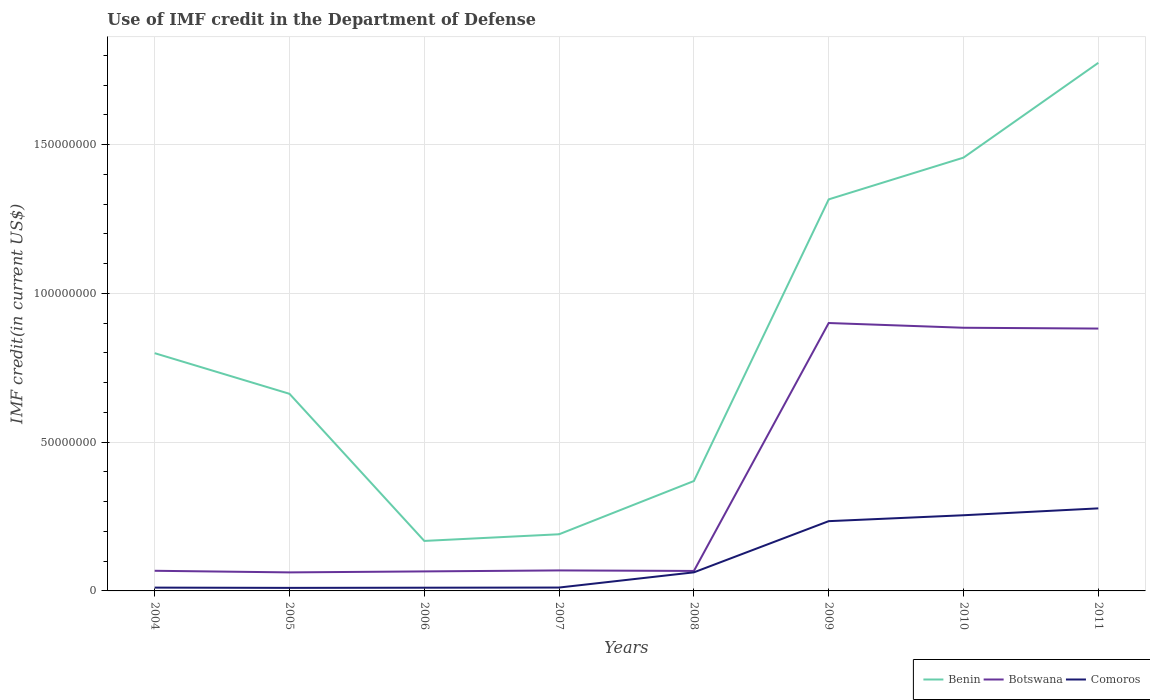How many different coloured lines are there?
Your answer should be compact. 3. Does the line corresponding to Comoros intersect with the line corresponding to Botswana?
Your answer should be compact. No. Is the number of lines equal to the number of legend labels?
Give a very brief answer. Yes. Across all years, what is the maximum IMF credit in the Department of Defense in Comoros?
Keep it short and to the point. 1.02e+06. What is the total IMF credit in the Department of Defense in Botswana in the graph?
Your response must be concise. -3.30e+05. What is the difference between the highest and the second highest IMF credit in the Department of Defense in Benin?
Keep it short and to the point. 1.61e+08. Is the IMF credit in the Department of Defense in Benin strictly greater than the IMF credit in the Department of Defense in Botswana over the years?
Give a very brief answer. No. How many lines are there?
Make the answer very short. 3. What is the difference between two consecutive major ticks on the Y-axis?
Make the answer very short. 5.00e+07. Where does the legend appear in the graph?
Provide a succinct answer. Bottom right. How many legend labels are there?
Ensure brevity in your answer.  3. What is the title of the graph?
Provide a short and direct response. Use of IMF credit in the Department of Defense. What is the label or title of the Y-axis?
Ensure brevity in your answer.  IMF credit(in current US$). What is the IMF credit(in current US$) of Benin in 2004?
Ensure brevity in your answer.  7.99e+07. What is the IMF credit(in current US$) in Botswana in 2004?
Your response must be concise. 6.77e+06. What is the IMF credit(in current US$) in Comoros in 2004?
Offer a very short reply. 1.11e+06. What is the IMF credit(in current US$) of Benin in 2005?
Make the answer very short. 6.62e+07. What is the IMF credit(in current US$) of Botswana in 2005?
Your answer should be very brief. 6.23e+06. What is the IMF credit(in current US$) in Comoros in 2005?
Your response must be concise. 1.02e+06. What is the IMF credit(in current US$) in Benin in 2006?
Your answer should be very brief. 1.68e+07. What is the IMF credit(in current US$) of Botswana in 2006?
Ensure brevity in your answer.  6.56e+06. What is the IMF credit(in current US$) in Comoros in 2006?
Your answer should be compact. 1.08e+06. What is the IMF credit(in current US$) in Benin in 2007?
Make the answer very short. 1.90e+07. What is the IMF credit(in current US$) in Botswana in 2007?
Provide a succinct answer. 6.89e+06. What is the IMF credit(in current US$) of Comoros in 2007?
Your answer should be compact. 1.14e+06. What is the IMF credit(in current US$) in Benin in 2008?
Provide a succinct answer. 3.69e+07. What is the IMF credit(in current US$) in Botswana in 2008?
Offer a terse response. 6.71e+06. What is the IMF credit(in current US$) in Comoros in 2008?
Provide a short and direct response. 6.24e+06. What is the IMF credit(in current US$) in Benin in 2009?
Your response must be concise. 1.32e+08. What is the IMF credit(in current US$) of Botswana in 2009?
Ensure brevity in your answer.  9.00e+07. What is the IMF credit(in current US$) in Comoros in 2009?
Provide a succinct answer. 2.34e+07. What is the IMF credit(in current US$) in Benin in 2010?
Your answer should be very brief. 1.46e+08. What is the IMF credit(in current US$) in Botswana in 2010?
Make the answer very short. 8.84e+07. What is the IMF credit(in current US$) of Comoros in 2010?
Offer a terse response. 2.54e+07. What is the IMF credit(in current US$) of Benin in 2011?
Give a very brief answer. 1.77e+08. What is the IMF credit(in current US$) of Botswana in 2011?
Ensure brevity in your answer.  8.82e+07. What is the IMF credit(in current US$) in Comoros in 2011?
Offer a terse response. 2.77e+07. Across all years, what is the maximum IMF credit(in current US$) in Benin?
Offer a terse response. 1.77e+08. Across all years, what is the maximum IMF credit(in current US$) of Botswana?
Offer a very short reply. 9.00e+07. Across all years, what is the maximum IMF credit(in current US$) of Comoros?
Your answer should be compact. 2.77e+07. Across all years, what is the minimum IMF credit(in current US$) in Benin?
Your response must be concise. 1.68e+07. Across all years, what is the minimum IMF credit(in current US$) in Botswana?
Make the answer very short. 6.23e+06. Across all years, what is the minimum IMF credit(in current US$) of Comoros?
Provide a succinct answer. 1.02e+06. What is the total IMF credit(in current US$) of Benin in the graph?
Your answer should be very brief. 6.74e+08. What is the total IMF credit(in current US$) of Botswana in the graph?
Keep it short and to the point. 3.00e+08. What is the total IMF credit(in current US$) in Comoros in the graph?
Offer a terse response. 8.72e+07. What is the difference between the IMF credit(in current US$) in Benin in 2004 and that in 2005?
Keep it short and to the point. 1.37e+07. What is the difference between the IMF credit(in current US$) of Botswana in 2004 and that in 2005?
Offer a very short reply. 5.40e+05. What is the difference between the IMF credit(in current US$) of Comoros in 2004 and that in 2005?
Your answer should be very brief. 8.80e+04. What is the difference between the IMF credit(in current US$) in Benin in 2004 and that in 2006?
Provide a succinct answer. 6.31e+07. What is the difference between the IMF credit(in current US$) of Botswana in 2004 and that in 2006?
Keep it short and to the point. 2.12e+05. What is the difference between the IMF credit(in current US$) in Comoros in 2004 and that in 2006?
Offer a terse response. 3.30e+04. What is the difference between the IMF credit(in current US$) in Benin in 2004 and that in 2007?
Provide a short and direct response. 6.09e+07. What is the difference between the IMF credit(in current US$) of Botswana in 2004 and that in 2007?
Offer a very short reply. -1.18e+05. What is the difference between the IMF credit(in current US$) in Comoros in 2004 and that in 2007?
Provide a succinct answer. -2.30e+04. What is the difference between the IMF credit(in current US$) in Benin in 2004 and that in 2008?
Provide a short and direct response. 4.30e+07. What is the difference between the IMF credit(in current US$) in Botswana in 2004 and that in 2008?
Your answer should be very brief. 5.60e+04. What is the difference between the IMF credit(in current US$) in Comoros in 2004 and that in 2008?
Make the answer very short. -5.13e+06. What is the difference between the IMF credit(in current US$) in Benin in 2004 and that in 2009?
Provide a short and direct response. -5.17e+07. What is the difference between the IMF credit(in current US$) of Botswana in 2004 and that in 2009?
Your response must be concise. -8.33e+07. What is the difference between the IMF credit(in current US$) in Comoros in 2004 and that in 2009?
Make the answer very short. -2.23e+07. What is the difference between the IMF credit(in current US$) of Benin in 2004 and that in 2010?
Offer a terse response. -6.57e+07. What is the difference between the IMF credit(in current US$) of Botswana in 2004 and that in 2010?
Make the answer very short. -8.17e+07. What is the difference between the IMF credit(in current US$) of Comoros in 2004 and that in 2010?
Make the answer very short. -2.43e+07. What is the difference between the IMF credit(in current US$) in Benin in 2004 and that in 2011?
Provide a succinct answer. -9.76e+07. What is the difference between the IMF credit(in current US$) in Botswana in 2004 and that in 2011?
Make the answer very short. -8.14e+07. What is the difference between the IMF credit(in current US$) in Comoros in 2004 and that in 2011?
Provide a short and direct response. -2.66e+07. What is the difference between the IMF credit(in current US$) of Benin in 2005 and that in 2006?
Offer a terse response. 4.94e+07. What is the difference between the IMF credit(in current US$) in Botswana in 2005 and that in 2006?
Offer a terse response. -3.28e+05. What is the difference between the IMF credit(in current US$) in Comoros in 2005 and that in 2006?
Ensure brevity in your answer.  -5.50e+04. What is the difference between the IMF credit(in current US$) of Benin in 2005 and that in 2007?
Provide a short and direct response. 4.72e+07. What is the difference between the IMF credit(in current US$) in Botswana in 2005 and that in 2007?
Keep it short and to the point. -6.58e+05. What is the difference between the IMF credit(in current US$) of Comoros in 2005 and that in 2007?
Provide a succinct answer. -1.11e+05. What is the difference between the IMF credit(in current US$) of Benin in 2005 and that in 2008?
Your response must be concise. 2.93e+07. What is the difference between the IMF credit(in current US$) in Botswana in 2005 and that in 2008?
Your answer should be very brief. -4.84e+05. What is the difference between the IMF credit(in current US$) in Comoros in 2005 and that in 2008?
Ensure brevity in your answer.  -5.22e+06. What is the difference between the IMF credit(in current US$) of Benin in 2005 and that in 2009?
Make the answer very short. -6.53e+07. What is the difference between the IMF credit(in current US$) of Botswana in 2005 and that in 2009?
Give a very brief answer. -8.38e+07. What is the difference between the IMF credit(in current US$) in Comoros in 2005 and that in 2009?
Provide a short and direct response. -2.24e+07. What is the difference between the IMF credit(in current US$) of Benin in 2005 and that in 2010?
Keep it short and to the point. -7.94e+07. What is the difference between the IMF credit(in current US$) in Botswana in 2005 and that in 2010?
Offer a very short reply. -8.22e+07. What is the difference between the IMF credit(in current US$) in Comoros in 2005 and that in 2010?
Provide a short and direct response. -2.44e+07. What is the difference between the IMF credit(in current US$) in Benin in 2005 and that in 2011?
Your answer should be very brief. -1.11e+08. What is the difference between the IMF credit(in current US$) in Botswana in 2005 and that in 2011?
Your response must be concise. -8.19e+07. What is the difference between the IMF credit(in current US$) in Comoros in 2005 and that in 2011?
Give a very brief answer. -2.67e+07. What is the difference between the IMF credit(in current US$) of Benin in 2006 and that in 2007?
Provide a succinct answer. -2.24e+06. What is the difference between the IMF credit(in current US$) of Botswana in 2006 and that in 2007?
Keep it short and to the point. -3.30e+05. What is the difference between the IMF credit(in current US$) in Comoros in 2006 and that in 2007?
Provide a succinct answer. -5.60e+04. What is the difference between the IMF credit(in current US$) in Benin in 2006 and that in 2008?
Make the answer very short. -2.01e+07. What is the difference between the IMF credit(in current US$) of Botswana in 2006 and that in 2008?
Your answer should be compact. -1.56e+05. What is the difference between the IMF credit(in current US$) of Comoros in 2006 and that in 2008?
Keep it short and to the point. -5.16e+06. What is the difference between the IMF credit(in current US$) of Benin in 2006 and that in 2009?
Offer a very short reply. -1.15e+08. What is the difference between the IMF credit(in current US$) in Botswana in 2006 and that in 2009?
Your answer should be compact. -8.35e+07. What is the difference between the IMF credit(in current US$) of Comoros in 2006 and that in 2009?
Offer a very short reply. -2.24e+07. What is the difference between the IMF credit(in current US$) of Benin in 2006 and that in 2010?
Your response must be concise. -1.29e+08. What is the difference between the IMF credit(in current US$) in Botswana in 2006 and that in 2010?
Your answer should be very brief. -8.19e+07. What is the difference between the IMF credit(in current US$) of Comoros in 2006 and that in 2010?
Make the answer very short. -2.44e+07. What is the difference between the IMF credit(in current US$) of Benin in 2006 and that in 2011?
Provide a succinct answer. -1.61e+08. What is the difference between the IMF credit(in current US$) in Botswana in 2006 and that in 2011?
Offer a terse response. -8.16e+07. What is the difference between the IMF credit(in current US$) of Comoros in 2006 and that in 2011?
Give a very brief answer. -2.67e+07. What is the difference between the IMF credit(in current US$) of Benin in 2007 and that in 2008?
Provide a short and direct response. -1.79e+07. What is the difference between the IMF credit(in current US$) in Botswana in 2007 and that in 2008?
Make the answer very short. 1.74e+05. What is the difference between the IMF credit(in current US$) of Comoros in 2007 and that in 2008?
Offer a very short reply. -5.11e+06. What is the difference between the IMF credit(in current US$) of Benin in 2007 and that in 2009?
Give a very brief answer. -1.13e+08. What is the difference between the IMF credit(in current US$) in Botswana in 2007 and that in 2009?
Make the answer very short. -8.31e+07. What is the difference between the IMF credit(in current US$) in Comoros in 2007 and that in 2009?
Make the answer very short. -2.23e+07. What is the difference between the IMF credit(in current US$) of Benin in 2007 and that in 2010?
Provide a short and direct response. -1.27e+08. What is the difference between the IMF credit(in current US$) in Botswana in 2007 and that in 2010?
Ensure brevity in your answer.  -8.16e+07. What is the difference between the IMF credit(in current US$) of Comoros in 2007 and that in 2010?
Give a very brief answer. -2.43e+07. What is the difference between the IMF credit(in current US$) of Benin in 2007 and that in 2011?
Ensure brevity in your answer.  -1.58e+08. What is the difference between the IMF credit(in current US$) of Botswana in 2007 and that in 2011?
Give a very brief answer. -8.13e+07. What is the difference between the IMF credit(in current US$) in Comoros in 2007 and that in 2011?
Provide a succinct answer. -2.66e+07. What is the difference between the IMF credit(in current US$) of Benin in 2008 and that in 2009?
Make the answer very short. -9.47e+07. What is the difference between the IMF credit(in current US$) in Botswana in 2008 and that in 2009?
Make the answer very short. -8.33e+07. What is the difference between the IMF credit(in current US$) of Comoros in 2008 and that in 2009?
Give a very brief answer. -1.72e+07. What is the difference between the IMF credit(in current US$) of Benin in 2008 and that in 2010?
Keep it short and to the point. -1.09e+08. What is the difference between the IMF credit(in current US$) of Botswana in 2008 and that in 2010?
Make the answer very short. -8.17e+07. What is the difference between the IMF credit(in current US$) of Comoros in 2008 and that in 2010?
Offer a terse response. -1.92e+07. What is the difference between the IMF credit(in current US$) in Benin in 2008 and that in 2011?
Ensure brevity in your answer.  -1.41e+08. What is the difference between the IMF credit(in current US$) in Botswana in 2008 and that in 2011?
Make the answer very short. -8.15e+07. What is the difference between the IMF credit(in current US$) of Comoros in 2008 and that in 2011?
Keep it short and to the point. -2.15e+07. What is the difference between the IMF credit(in current US$) in Benin in 2009 and that in 2010?
Offer a very short reply. -1.40e+07. What is the difference between the IMF credit(in current US$) of Botswana in 2009 and that in 2010?
Your answer should be very brief. 1.59e+06. What is the difference between the IMF credit(in current US$) of Comoros in 2009 and that in 2010?
Provide a short and direct response. -1.98e+06. What is the difference between the IMF credit(in current US$) in Benin in 2009 and that in 2011?
Ensure brevity in your answer.  -4.59e+07. What is the difference between the IMF credit(in current US$) in Botswana in 2009 and that in 2011?
Your response must be concise. 1.86e+06. What is the difference between the IMF credit(in current US$) in Comoros in 2009 and that in 2011?
Make the answer very short. -4.30e+06. What is the difference between the IMF credit(in current US$) in Benin in 2010 and that in 2011?
Your answer should be compact. -3.19e+07. What is the difference between the IMF credit(in current US$) of Botswana in 2010 and that in 2011?
Ensure brevity in your answer.  2.73e+05. What is the difference between the IMF credit(in current US$) of Comoros in 2010 and that in 2011?
Your answer should be very brief. -2.31e+06. What is the difference between the IMF credit(in current US$) in Benin in 2004 and the IMF credit(in current US$) in Botswana in 2005?
Offer a very short reply. 7.37e+07. What is the difference between the IMF credit(in current US$) in Benin in 2004 and the IMF credit(in current US$) in Comoros in 2005?
Offer a terse response. 7.89e+07. What is the difference between the IMF credit(in current US$) in Botswana in 2004 and the IMF credit(in current US$) in Comoros in 2005?
Your answer should be very brief. 5.74e+06. What is the difference between the IMF credit(in current US$) in Benin in 2004 and the IMF credit(in current US$) in Botswana in 2006?
Provide a succinct answer. 7.33e+07. What is the difference between the IMF credit(in current US$) in Benin in 2004 and the IMF credit(in current US$) in Comoros in 2006?
Provide a succinct answer. 7.88e+07. What is the difference between the IMF credit(in current US$) of Botswana in 2004 and the IMF credit(in current US$) of Comoros in 2006?
Keep it short and to the point. 5.69e+06. What is the difference between the IMF credit(in current US$) of Benin in 2004 and the IMF credit(in current US$) of Botswana in 2007?
Make the answer very short. 7.30e+07. What is the difference between the IMF credit(in current US$) of Benin in 2004 and the IMF credit(in current US$) of Comoros in 2007?
Provide a succinct answer. 7.88e+07. What is the difference between the IMF credit(in current US$) in Botswana in 2004 and the IMF credit(in current US$) in Comoros in 2007?
Offer a very short reply. 5.63e+06. What is the difference between the IMF credit(in current US$) of Benin in 2004 and the IMF credit(in current US$) of Botswana in 2008?
Your response must be concise. 7.32e+07. What is the difference between the IMF credit(in current US$) in Benin in 2004 and the IMF credit(in current US$) in Comoros in 2008?
Give a very brief answer. 7.37e+07. What is the difference between the IMF credit(in current US$) of Botswana in 2004 and the IMF credit(in current US$) of Comoros in 2008?
Your response must be concise. 5.26e+05. What is the difference between the IMF credit(in current US$) of Benin in 2004 and the IMF credit(in current US$) of Botswana in 2009?
Offer a very short reply. -1.01e+07. What is the difference between the IMF credit(in current US$) of Benin in 2004 and the IMF credit(in current US$) of Comoros in 2009?
Your answer should be compact. 5.65e+07. What is the difference between the IMF credit(in current US$) of Botswana in 2004 and the IMF credit(in current US$) of Comoros in 2009?
Provide a short and direct response. -1.67e+07. What is the difference between the IMF credit(in current US$) of Benin in 2004 and the IMF credit(in current US$) of Botswana in 2010?
Your response must be concise. -8.55e+06. What is the difference between the IMF credit(in current US$) in Benin in 2004 and the IMF credit(in current US$) in Comoros in 2010?
Your answer should be compact. 5.45e+07. What is the difference between the IMF credit(in current US$) of Botswana in 2004 and the IMF credit(in current US$) of Comoros in 2010?
Make the answer very short. -1.87e+07. What is the difference between the IMF credit(in current US$) in Benin in 2004 and the IMF credit(in current US$) in Botswana in 2011?
Provide a short and direct response. -8.27e+06. What is the difference between the IMF credit(in current US$) in Benin in 2004 and the IMF credit(in current US$) in Comoros in 2011?
Provide a succinct answer. 5.22e+07. What is the difference between the IMF credit(in current US$) of Botswana in 2004 and the IMF credit(in current US$) of Comoros in 2011?
Your answer should be very brief. -2.10e+07. What is the difference between the IMF credit(in current US$) in Benin in 2005 and the IMF credit(in current US$) in Botswana in 2006?
Make the answer very short. 5.97e+07. What is the difference between the IMF credit(in current US$) of Benin in 2005 and the IMF credit(in current US$) of Comoros in 2006?
Make the answer very short. 6.52e+07. What is the difference between the IMF credit(in current US$) of Botswana in 2005 and the IMF credit(in current US$) of Comoros in 2006?
Your response must be concise. 5.15e+06. What is the difference between the IMF credit(in current US$) of Benin in 2005 and the IMF credit(in current US$) of Botswana in 2007?
Offer a terse response. 5.94e+07. What is the difference between the IMF credit(in current US$) in Benin in 2005 and the IMF credit(in current US$) in Comoros in 2007?
Your answer should be compact. 6.51e+07. What is the difference between the IMF credit(in current US$) of Botswana in 2005 and the IMF credit(in current US$) of Comoros in 2007?
Keep it short and to the point. 5.09e+06. What is the difference between the IMF credit(in current US$) in Benin in 2005 and the IMF credit(in current US$) in Botswana in 2008?
Make the answer very short. 5.95e+07. What is the difference between the IMF credit(in current US$) of Benin in 2005 and the IMF credit(in current US$) of Comoros in 2008?
Your answer should be very brief. 6.00e+07. What is the difference between the IMF credit(in current US$) of Botswana in 2005 and the IMF credit(in current US$) of Comoros in 2008?
Give a very brief answer. -1.40e+04. What is the difference between the IMF credit(in current US$) in Benin in 2005 and the IMF credit(in current US$) in Botswana in 2009?
Your response must be concise. -2.38e+07. What is the difference between the IMF credit(in current US$) of Benin in 2005 and the IMF credit(in current US$) of Comoros in 2009?
Ensure brevity in your answer.  4.28e+07. What is the difference between the IMF credit(in current US$) in Botswana in 2005 and the IMF credit(in current US$) in Comoros in 2009?
Offer a very short reply. -1.72e+07. What is the difference between the IMF credit(in current US$) of Benin in 2005 and the IMF credit(in current US$) of Botswana in 2010?
Your answer should be compact. -2.22e+07. What is the difference between the IMF credit(in current US$) in Benin in 2005 and the IMF credit(in current US$) in Comoros in 2010?
Your answer should be compact. 4.08e+07. What is the difference between the IMF credit(in current US$) in Botswana in 2005 and the IMF credit(in current US$) in Comoros in 2010?
Offer a very short reply. -1.92e+07. What is the difference between the IMF credit(in current US$) of Benin in 2005 and the IMF credit(in current US$) of Botswana in 2011?
Provide a short and direct response. -2.19e+07. What is the difference between the IMF credit(in current US$) of Benin in 2005 and the IMF credit(in current US$) of Comoros in 2011?
Your response must be concise. 3.85e+07. What is the difference between the IMF credit(in current US$) in Botswana in 2005 and the IMF credit(in current US$) in Comoros in 2011?
Your answer should be very brief. -2.15e+07. What is the difference between the IMF credit(in current US$) of Benin in 2006 and the IMF credit(in current US$) of Botswana in 2007?
Make the answer very short. 9.92e+06. What is the difference between the IMF credit(in current US$) of Benin in 2006 and the IMF credit(in current US$) of Comoros in 2007?
Your answer should be compact. 1.57e+07. What is the difference between the IMF credit(in current US$) of Botswana in 2006 and the IMF credit(in current US$) of Comoros in 2007?
Give a very brief answer. 5.42e+06. What is the difference between the IMF credit(in current US$) in Benin in 2006 and the IMF credit(in current US$) in Botswana in 2008?
Make the answer very short. 1.01e+07. What is the difference between the IMF credit(in current US$) of Benin in 2006 and the IMF credit(in current US$) of Comoros in 2008?
Offer a terse response. 1.06e+07. What is the difference between the IMF credit(in current US$) in Botswana in 2006 and the IMF credit(in current US$) in Comoros in 2008?
Offer a very short reply. 3.14e+05. What is the difference between the IMF credit(in current US$) of Benin in 2006 and the IMF credit(in current US$) of Botswana in 2009?
Your answer should be compact. -7.32e+07. What is the difference between the IMF credit(in current US$) in Benin in 2006 and the IMF credit(in current US$) in Comoros in 2009?
Your answer should be very brief. -6.64e+06. What is the difference between the IMF credit(in current US$) of Botswana in 2006 and the IMF credit(in current US$) of Comoros in 2009?
Keep it short and to the point. -1.69e+07. What is the difference between the IMF credit(in current US$) of Benin in 2006 and the IMF credit(in current US$) of Botswana in 2010?
Your answer should be compact. -7.16e+07. What is the difference between the IMF credit(in current US$) of Benin in 2006 and the IMF credit(in current US$) of Comoros in 2010?
Provide a short and direct response. -8.63e+06. What is the difference between the IMF credit(in current US$) of Botswana in 2006 and the IMF credit(in current US$) of Comoros in 2010?
Offer a very short reply. -1.89e+07. What is the difference between the IMF credit(in current US$) in Benin in 2006 and the IMF credit(in current US$) in Botswana in 2011?
Keep it short and to the point. -7.14e+07. What is the difference between the IMF credit(in current US$) of Benin in 2006 and the IMF credit(in current US$) of Comoros in 2011?
Provide a succinct answer. -1.09e+07. What is the difference between the IMF credit(in current US$) of Botswana in 2006 and the IMF credit(in current US$) of Comoros in 2011?
Make the answer very short. -2.12e+07. What is the difference between the IMF credit(in current US$) of Benin in 2007 and the IMF credit(in current US$) of Botswana in 2008?
Offer a very short reply. 1.23e+07. What is the difference between the IMF credit(in current US$) in Benin in 2007 and the IMF credit(in current US$) in Comoros in 2008?
Your answer should be compact. 1.28e+07. What is the difference between the IMF credit(in current US$) of Botswana in 2007 and the IMF credit(in current US$) of Comoros in 2008?
Provide a succinct answer. 6.44e+05. What is the difference between the IMF credit(in current US$) of Benin in 2007 and the IMF credit(in current US$) of Botswana in 2009?
Offer a terse response. -7.10e+07. What is the difference between the IMF credit(in current US$) in Benin in 2007 and the IMF credit(in current US$) in Comoros in 2009?
Your answer should be very brief. -4.40e+06. What is the difference between the IMF credit(in current US$) of Botswana in 2007 and the IMF credit(in current US$) of Comoros in 2009?
Offer a terse response. -1.66e+07. What is the difference between the IMF credit(in current US$) of Benin in 2007 and the IMF credit(in current US$) of Botswana in 2010?
Ensure brevity in your answer.  -6.94e+07. What is the difference between the IMF credit(in current US$) of Benin in 2007 and the IMF credit(in current US$) of Comoros in 2010?
Provide a succinct answer. -6.39e+06. What is the difference between the IMF credit(in current US$) in Botswana in 2007 and the IMF credit(in current US$) in Comoros in 2010?
Provide a succinct answer. -1.85e+07. What is the difference between the IMF credit(in current US$) of Benin in 2007 and the IMF credit(in current US$) of Botswana in 2011?
Your answer should be very brief. -6.91e+07. What is the difference between the IMF credit(in current US$) in Benin in 2007 and the IMF credit(in current US$) in Comoros in 2011?
Your answer should be very brief. -8.70e+06. What is the difference between the IMF credit(in current US$) in Botswana in 2007 and the IMF credit(in current US$) in Comoros in 2011?
Provide a short and direct response. -2.09e+07. What is the difference between the IMF credit(in current US$) in Benin in 2008 and the IMF credit(in current US$) in Botswana in 2009?
Keep it short and to the point. -5.31e+07. What is the difference between the IMF credit(in current US$) of Benin in 2008 and the IMF credit(in current US$) of Comoros in 2009?
Keep it short and to the point. 1.35e+07. What is the difference between the IMF credit(in current US$) in Botswana in 2008 and the IMF credit(in current US$) in Comoros in 2009?
Offer a very short reply. -1.67e+07. What is the difference between the IMF credit(in current US$) in Benin in 2008 and the IMF credit(in current US$) in Botswana in 2010?
Keep it short and to the point. -5.15e+07. What is the difference between the IMF credit(in current US$) of Benin in 2008 and the IMF credit(in current US$) of Comoros in 2010?
Keep it short and to the point. 1.15e+07. What is the difference between the IMF credit(in current US$) in Botswana in 2008 and the IMF credit(in current US$) in Comoros in 2010?
Keep it short and to the point. -1.87e+07. What is the difference between the IMF credit(in current US$) of Benin in 2008 and the IMF credit(in current US$) of Botswana in 2011?
Give a very brief answer. -5.12e+07. What is the difference between the IMF credit(in current US$) in Benin in 2008 and the IMF credit(in current US$) in Comoros in 2011?
Provide a short and direct response. 9.19e+06. What is the difference between the IMF credit(in current US$) in Botswana in 2008 and the IMF credit(in current US$) in Comoros in 2011?
Provide a short and direct response. -2.10e+07. What is the difference between the IMF credit(in current US$) of Benin in 2009 and the IMF credit(in current US$) of Botswana in 2010?
Your response must be concise. 4.31e+07. What is the difference between the IMF credit(in current US$) in Benin in 2009 and the IMF credit(in current US$) in Comoros in 2010?
Keep it short and to the point. 1.06e+08. What is the difference between the IMF credit(in current US$) in Botswana in 2009 and the IMF credit(in current US$) in Comoros in 2010?
Ensure brevity in your answer.  6.46e+07. What is the difference between the IMF credit(in current US$) in Benin in 2009 and the IMF credit(in current US$) in Botswana in 2011?
Give a very brief answer. 4.34e+07. What is the difference between the IMF credit(in current US$) in Benin in 2009 and the IMF credit(in current US$) in Comoros in 2011?
Provide a short and direct response. 1.04e+08. What is the difference between the IMF credit(in current US$) in Botswana in 2009 and the IMF credit(in current US$) in Comoros in 2011?
Provide a succinct answer. 6.23e+07. What is the difference between the IMF credit(in current US$) in Benin in 2010 and the IMF credit(in current US$) in Botswana in 2011?
Keep it short and to the point. 5.74e+07. What is the difference between the IMF credit(in current US$) of Benin in 2010 and the IMF credit(in current US$) of Comoros in 2011?
Keep it short and to the point. 1.18e+08. What is the difference between the IMF credit(in current US$) in Botswana in 2010 and the IMF credit(in current US$) in Comoros in 2011?
Keep it short and to the point. 6.07e+07. What is the average IMF credit(in current US$) of Benin per year?
Your response must be concise. 8.42e+07. What is the average IMF credit(in current US$) in Botswana per year?
Give a very brief answer. 3.75e+07. What is the average IMF credit(in current US$) of Comoros per year?
Make the answer very short. 1.09e+07. In the year 2004, what is the difference between the IMF credit(in current US$) of Benin and IMF credit(in current US$) of Botswana?
Keep it short and to the point. 7.31e+07. In the year 2004, what is the difference between the IMF credit(in current US$) in Benin and IMF credit(in current US$) in Comoros?
Give a very brief answer. 7.88e+07. In the year 2004, what is the difference between the IMF credit(in current US$) of Botswana and IMF credit(in current US$) of Comoros?
Your response must be concise. 5.66e+06. In the year 2005, what is the difference between the IMF credit(in current US$) of Benin and IMF credit(in current US$) of Botswana?
Ensure brevity in your answer.  6.00e+07. In the year 2005, what is the difference between the IMF credit(in current US$) in Benin and IMF credit(in current US$) in Comoros?
Your answer should be compact. 6.52e+07. In the year 2005, what is the difference between the IMF credit(in current US$) in Botswana and IMF credit(in current US$) in Comoros?
Provide a succinct answer. 5.20e+06. In the year 2006, what is the difference between the IMF credit(in current US$) of Benin and IMF credit(in current US$) of Botswana?
Your answer should be very brief. 1.02e+07. In the year 2006, what is the difference between the IMF credit(in current US$) in Benin and IMF credit(in current US$) in Comoros?
Offer a terse response. 1.57e+07. In the year 2006, what is the difference between the IMF credit(in current US$) of Botswana and IMF credit(in current US$) of Comoros?
Offer a very short reply. 5.48e+06. In the year 2007, what is the difference between the IMF credit(in current US$) in Benin and IMF credit(in current US$) in Botswana?
Offer a terse response. 1.22e+07. In the year 2007, what is the difference between the IMF credit(in current US$) of Benin and IMF credit(in current US$) of Comoros?
Keep it short and to the point. 1.79e+07. In the year 2007, what is the difference between the IMF credit(in current US$) in Botswana and IMF credit(in current US$) in Comoros?
Your response must be concise. 5.75e+06. In the year 2008, what is the difference between the IMF credit(in current US$) of Benin and IMF credit(in current US$) of Botswana?
Ensure brevity in your answer.  3.02e+07. In the year 2008, what is the difference between the IMF credit(in current US$) in Benin and IMF credit(in current US$) in Comoros?
Your answer should be compact. 3.07e+07. In the year 2009, what is the difference between the IMF credit(in current US$) of Benin and IMF credit(in current US$) of Botswana?
Provide a succinct answer. 4.16e+07. In the year 2009, what is the difference between the IMF credit(in current US$) of Benin and IMF credit(in current US$) of Comoros?
Give a very brief answer. 1.08e+08. In the year 2009, what is the difference between the IMF credit(in current US$) in Botswana and IMF credit(in current US$) in Comoros?
Your answer should be compact. 6.66e+07. In the year 2010, what is the difference between the IMF credit(in current US$) of Benin and IMF credit(in current US$) of Botswana?
Offer a very short reply. 5.72e+07. In the year 2010, what is the difference between the IMF credit(in current US$) of Benin and IMF credit(in current US$) of Comoros?
Provide a short and direct response. 1.20e+08. In the year 2010, what is the difference between the IMF credit(in current US$) of Botswana and IMF credit(in current US$) of Comoros?
Offer a terse response. 6.30e+07. In the year 2011, what is the difference between the IMF credit(in current US$) in Benin and IMF credit(in current US$) in Botswana?
Give a very brief answer. 8.93e+07. In the year 2011, what is the difference between the IMF credit(in current US$) of Benin and IMF credit(in current US$) of Comoros?
Your answer should be compact. 1.50e+08. In the year 2011, what is the difference between the IMF credit(in current US$) in Botswana and IMF credit(in current US$) in Comoros?
Offer a very short reply. 6.04e+07. What is the ratio of the IMF credit(in current US$) of Benin in 2004 to that in 2005?
Keep it short and to the point. 1.21. What is the ratio of the IMF credit(in current US$) of Botswana in 2004 to that in 2005?
Offer a very short reply. 1.09. What is the ratio of the IMF credit(in current US$) of Comoros in 2004 to that in 2005?
Make the answer very short. 1.09. What is the ratio of the IMF credit(in current US$) of Benin in 2004 to that in 2006?
Provide a succinct answer. 4.76. What is the ratio of the IMF credit(in current US$) in Botswana in 2004 to that in 2006?
Your answer should be compact. 1.03. What is the ratio of the IMF credit(in current US$) in Comoros in 2004 to that in 2006?
Provide a short and direct response. 1.03. What is the ratio of the IMF credit(in current US$) in Benin in 2004 to that in 2007?
Ensure brevity in your answer.  4.2. What is the ratio of the IMF credit(in current US$) of Botswana in 2004 to that in 2007?
Your response must be concise. 0.98. What is the ratio of the IMF credit(in current US$) in Comoros in 2004 to that in 2007?
Offer a terse response. 0.98. What is the ratio of the IMF credit(in current US$) of Benin in 2004 to that in 2008?
Your response must be concise. 2.16. What is the ratio of the IMF credit(in current US$) of Botswana in 2004 to that in 2008?
Offer a very short reply. 1.01. What is the ratio of the IMF credit(in current US$) in Comoros in 2004 to that in 2008?
Your response must be concise. 0.18. What is the ratio of the IMF credit(in current US$) of Benin in 2004 to that in 2009?
Provide a succinct answer. 0.61. What is the ratio of the IMF credit(in current US$) in Botswana in 2004 to that in 2009?
Provide a short and direct response. 0.08. What is the ratio of the IMF credit(in current US$) of Comoros in 2004 to that in 2009?
Provide a succinct answer. 0.05. What is the ratio of the IMF credit(in current US$) in Benin in 2004 to that in 2010?
Your response must be concise. 0.55. What is the ratio of the IMF credit(in current US$) in Botswana in 2004 to that in 2010?
Offer a terse response. 0.08. What is the ratio of the IMF credit(in current US$) of Comoros in 2004 to that in 2010?
Provide a short and direct response. 0.04. What is the ratio of the IMF credit(in current US$) of Benin in 2004 to that in 2011?
Give a very brief answer. 0.45. What is the ratio of the IMF credit(in current US$) of Botswana in 2004 to that in 2011?
Give a very brief answer. 0.08. What is the ratio of the IMF credit(in current US$) in Comoros in 2004 to that in 2011?
Your answer should be very brief. 0.04. What is the ratio of the IMF credit(in current US$) in Benin in 2005 to that in 2006?
Ensure brevity in your answer.  3.94. What is the ratio of the IMF credit(in current US$) in Botswana in 2005 to that in 2006?
Your response must be concise. 0.95. What is the ratio of the IMF credit(in current US$) in Comoros in 2005 to that in 2006?
Make the answer very short. 0.95. What is the ratio of the IMF credit(in current US$) of Benin in 2005 to that in 2007?
Your response must be concise. 3.48. What is the ratio of the IMF credit(in current US$) of Botswana in 2005 to that in 2007?
Provide a succinct answer. 0.9. What is the ratio of the IMF credit(in current US$) in Comoros in 2005 to that in 2007?
Offer a terse response. 0.9. What is the ratio of the IMF credit(in current US$) of Benin in 2005 to that in 2008?
Ensure brevity in your answer.  1.79. What is the ratio of the IMF credit(in current US$) in Botswana in 2005 to that in 2008?
Ensure brevity in your answer.  0.93. What is the ratio of the IMF credit(in current US$) in Comoros in 2005 to that in 2008?
Ensure brevity in your answer.  0.16. What is the ratio of the IMF credit(in current US$) of Benin in 2005 to that in 2009?
Offer a terse response. 0.5. What is the ratio of the IMF credit(in current US$) in Botswana in 2005 to that in 2009?
Offer a very short reply. 0.07. What is the ratio of the IMF credit(in current US$) of Comoros in 2005 to that in 2009?
Your answer should be compact. 0.04. What is the ratio of the IMF credit(in current US$) in Benin in 2005 to that in 2010?
Keep it short and to the point. 0.45. What is the ratio of the IMF credit(in current US$) of Botswana in 2005 to that in 2010?
Offer a very short reply. 0.07. What is the ratio of the IMF credit(in current US$) in Comoros in 2005 to that in 2010?
Ensure brevity in your answer.  0.04. What is the ratio of the IMF credit(in current US$) of Benin in 2005 to that in 2011?
Your response must be concise. 0.37. What is the ratio of the IMF credit(in current US$) of Botswana in 2005 to that in 2011?
Offer a very short reply. 0.07. What is the ratio of the IMF credit(in current US$) of Comoros in 2005 to that in 2011?
Your answer should be compact. 0.04. What is the ratio of the IMF credit(in current US$) in Benin in 2006 to that in 2007?
Give a very brief answer. 0.88. What is the ratio of the IMF credit(in current US$) in Botswana in 2006 to that in 2007?
Ensure brevity in your answer.  0.95. What is the ratio of the IMF credit(in current US$) in Comoros in 2006 to that in 2007?
Give a very brief answer. 0.95. What is the ratio of the IMF credit(in current US$) of Benin in 2006 to that in 2008?
Make the answer very short. 0.45. What is the ratio of the IMF credit(in current US$) of Botswana in 2006 to that in 2008?
Make the answer very short. 0.98. What is the ratio of the IMF credit(in current US$) in Comoros in 2006 to that in 2008?
Provide a short and direct response. 0.17. What is the ratio of the IMF credit(in current US$) of Benin in 2006 to that in 2009?
Your response must be concise. 0.13. What is the ratio of the IMF credit(in current US$) of Botswana in 2006 to that in 2009?
Provide a succinct answer. 0.07. What is the ratio of the IMF credit(in current US$) of Comoros in 2006 to that in 2009?
Give a very brief answer. 0.05. What is the ratio of the IMF credit(in current US$) of Benin in 2006 to that in 2010?
Provide a succinct answer. 0.12. What is the ratio of the IMF credit(in current US$) in Botswana in 2006 to that in 2010?
Provide a short and direct response. 0.07. What is the ratio of the IMF credit(in current US$) of Comoros in 2006 to that in 2010?
Offer a terse response. 0.04. What is the ratio of the IMF credit(in current US$) of Benin in 2006 to that in 2011?
Give a very brief answer. 0.09. What is the ratio of the IMF credit(in current US$) in Botswana in 2006 to that in 2011?
Provide a succinct answer. 0.07. What is the ratio of the IMF credit(in current US$) in Comoros in 2006 to that in 2011?
Provide a succinct answer. 0.04. What is the ratio of the IMF credit(in current US$) of Benin in 2007 to that in 2008?
Provide a succinct answer. 0.52. What is the ratio of the IMF credit(in current US$) in Botswana in 2007 to that in 2008?
Keep it short and to the point. 1.03. What is the ratio of the IMF credit(in current US$) of Comoros in 2007 to that in 2008?
Your answer should be compact. 0.18. What is the ratio of the IMF credit(in current US$) of Benin in 2007 to that in 2009?
Provide a succinct answer. 0.14. What is the ratio of the IMF credit(in current US$) of Botswana in 2007 to that in 2009?
Your answer should be very brief. 0.08. What is the ratio of the IMF credit(in current US$) of Comoros in 2007 to that in 2009?
Ensure brevity in your answer.  0.05. What is the ratio of the IMF credit(in current US$) of Benin in 2007 to that in 2010?
Provide a succinct answer. 0.13. What is the ratio of the IMF credit(in current US$) in Botswana in 2007 to that in 2010?
Your answer should be compact. 0.08. What is the ratio of the IMF credit(in current US$) of Comoros in 2007 to that in 2010?
Provide a short and direct response. 0.04. What is the ratio of the IMF credit(in current US$) in Benin in 2007 to that in 2011?
Provide a short and direct response. 0.11. What is the ratio of the IMF credit(in current US$) in Botswana in 2007 to that in 2011?
Make the answer very short. 0.08. What is the ratio of the IMF credit(in current US$) in Comoros in 2007 to that in 2011?
Your response must be concise. 0.04. What is the ratio of the IMF credit(in current US$) in Benin in 2008 to that in 2009?
Keep it short and to the point. 0.28. What is the ratio of the IMF credit(in current US$) of Botswana in 2008 to that in 2009?
Make the answer very short. 0.07. What is the ratio of the IMF credit(in current US$) in Comoros in 2008 to that in 2009?
Provide a succinct answer. 0.27. What is the ratio of the IMF credit(in current US$) in Benin in 2008 to that in 2010?
Your answer should be very brief. 0.25. What is the ratio of the IMF credit(in current US$) in Botswana in 2008 to that in 2010?
Your response must be concise. 0.08. What is the ratio of the IMF credit(in current US$) of Comoros in 2008 to that in 2010?
Provide a succinct answer. 0.25. What is the ratio of the IMF credit(in current US$) of Benin in 2008 to that in 2011?
Offer a terse response. 0.21. What is the ratio of the IMF credit(in current US$) of Botswana in 2008 to that in 2011?
Your response must be concise. 0.08. What is the ratio of the IMF credit(in current US$) in Comoros in 2008 to that in 2011?
Give a very brief answer. 0.23. What is the ratio of the IMF credit(in current US$) of Benin in 2009 to that in 2010?
Provide a succinct answer. 0.9. What is the ratio of the IMF credit(in current US$) in Botswana in 2009 to that in 2010?
Your response must be concise. 1.02. What is the ratio of the IMF credit(in current US$) in Comoros in 2009 to that in 2010?
Offer a terse response. 0.92. What is the ratio of the IMF credit(in current US$) of Benin in 2009 to that in 2011?
Provide a succinct answer. 0.74. What is the ratio of the IMF credit(in current US$) of Botswana in 2009 to that in 2011?
Your answer should be very brief. 1.02. What is the ratio of the IMF credit(in current US$) in Comoros in 2009 to that in 2011?
Ensure brevity in your answer.  0.85. What is the ratio of the IMF credit(in current US$) in Benin in 2010 to that in 2011?
Keep it short and to the point. 0.82. What is the ratio of the IMF credit(in current US$) of Comoros in 2010 to that in 2011?
Provide a short and direct response. 0.92. What is the difference between the highest and the second highest IMF credit(in current US$) in Benin?
Keep it short and to the point. 3.19e+07. What is the difference between the highest and the second highest IMF credit(in current US$) in Botswana?
Your answer should be compact. 1.59e+06. What is the difference between the highest and the second highest IMF credit(in current US$) in Comoros?
Make the answer very short. 2.31e+06. What is the difference between the highest and the lowest IMF credit(in current US$) in Benin?
Keep it short and to the point. 1.61e+08. What is the difference between the highest and the lowest IMF credit(in current US$) in Botswana?
Give a very brief answer. 8.38e+07. What is the difference between the highest and the lowest IMF credit(in current US$) in Comoros?
Give a very brief answer. 2.67e+07. 